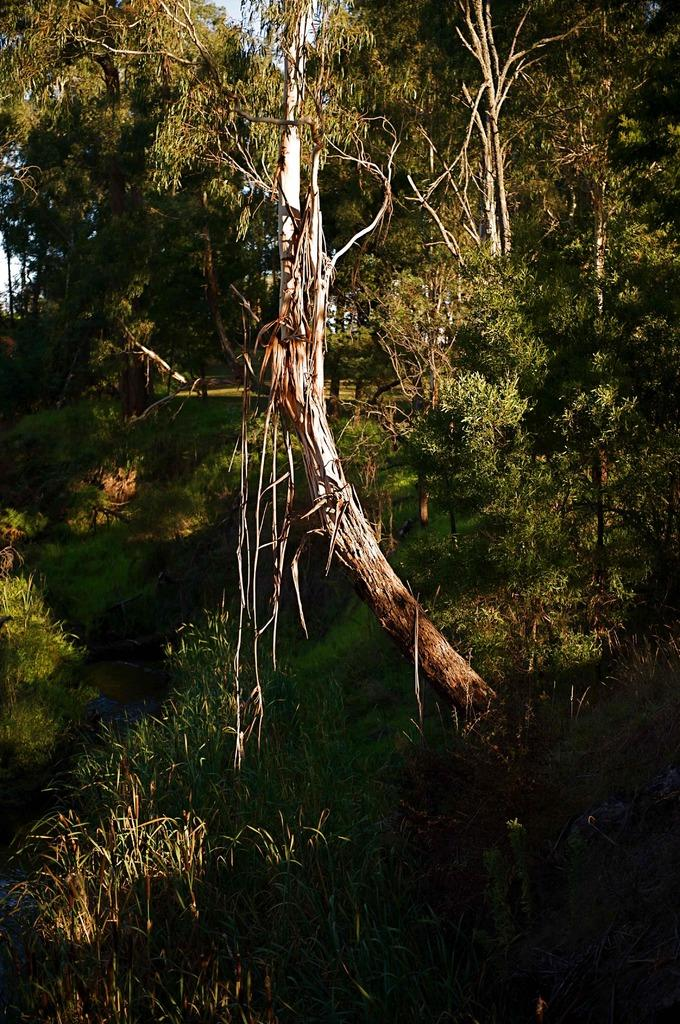What type of vegetation can be seen in the image? There are trees with branches and leaves in the image. What is visible at the bottom of the image? There is grass visible at the bottom of the image. What part of the natural environment is visible in the background of the image? The sky is visible in the background of the image. What type of ticket can be seen hanging from the branches of the trees in the image? There is no ticket present in the image; it features trees with branches and leaves, grass, and the sky. 